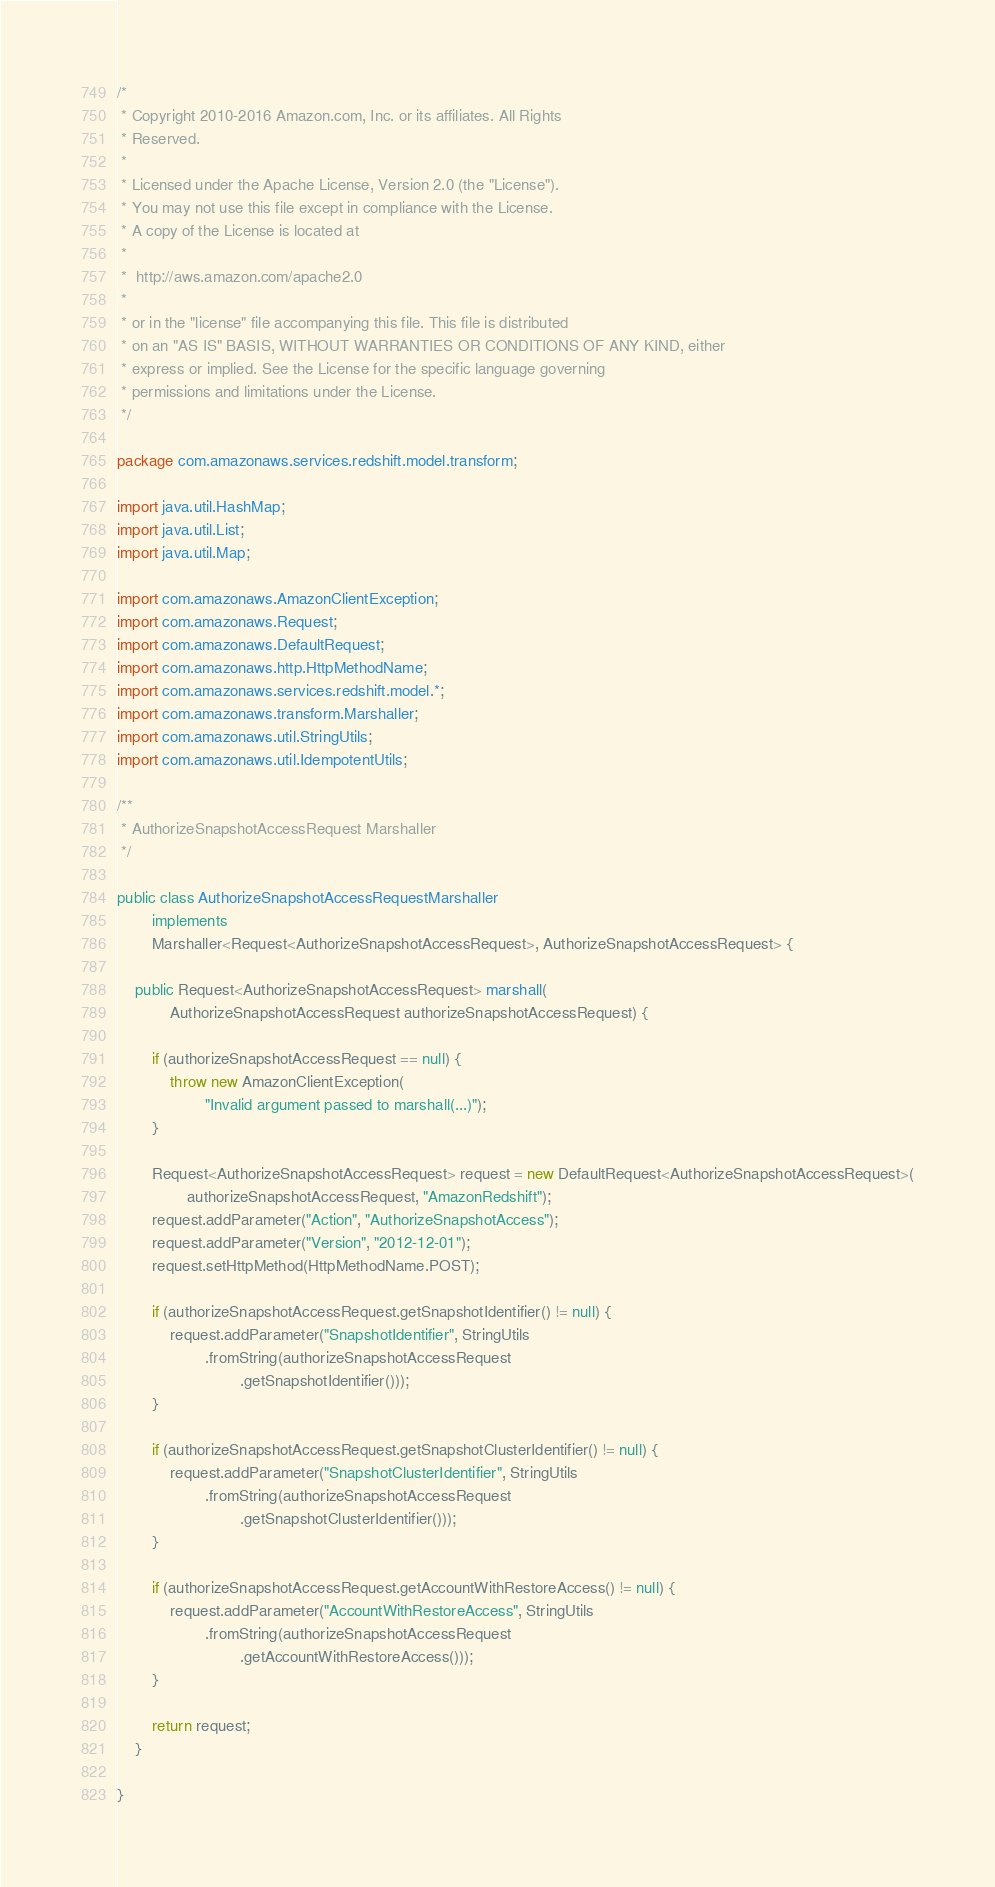<code> <loc_0><loc_0><loc_500><loc_500><_Java_>/*
 * Copyright 2010-2016 Amazon.com, Inc. or its affiliates. All Rights
 * Reserved.
 *
 * Licensed under the Apache License, Version 2.0 (the "License").
 * You may not use this file except in compliance with the License.
 * A copy of the License is located at
 *
 *  http://aws.amazon.com/apache2.0
 *
 * or in the "license" file accompanying this file. This file is distributed
 * on an "AS IS" BASIS, WITHOUT WARRANTIES OR CONDITIONS OF ANY KIND, either
 * express or implied. See the License for the specific language governing
 * permissions and limitations under the License.
 */

package com.amazonaws.services.redshift.model.transform;

import java.util.HashMap;
import java.util.List;
import java.util.Map;

import com.amazonaws.AmazonClientException;
import com.amazonaws.Request;
import com.amazonaws.DefaultRequest;
import com.amazonaws.http.HttpMethodName;
import com.amazonaws.services.redshift.model.*;
import com.amazonaws.transform.Marshaller;
import com.amazonaws.util.StringUtils;
import com.amazonaws.util.IdempotentUtils;

/**
 * AuthorizeSnapshotAccessRequest Marshaller
 */

public class AuthorizeSnapshotAccessRequestMarshaller
        implements
        Marshaller<Request<AuthorizeSnapshotAccessRequest>, AuthorizeSnapshotAccessRequest> {

    public Request<AuthorizeSnapshotAccessRequest> marshall(
            AuthorizeSnapshotAccessRequest authorizeSnapshotAccessRequest) {

        if (authorizeSnapshotAccessRequest == null) {
            throw new AmazonClientException(
                    "Invalid argument passed to marshall(...)");
        }

        Request<AuthorizeSnapshotAccessRequest> request = new DefaultRequest<AuthorizeSnapshotAccessRequest>(
                authorizeSnapshotAccessRequest, "AmazonRedshift");
        request.addParameter("Action", "AuthorizeSnapshotAccess");
        request.addParameter("Version", "2012-12-01");
        request.setHttpMethod(HttpMethodName.POST);

        if (authorizeSnapshotAccessRequest.getSnapshotIdentifier() != null) {
            request.addParameter("SnapshotIdentifier", StringUtils
                    .fromString(authorizeSnapshotAccessRequest
                            .getSnapshotIdentifier()));
        }

        if (authorizeSnapshotAccessRequest.getSnapshotClusterIdentifier() != null) {
            request.addParameter("SnapshotClusterIdentifier", StringUtils
                    .fromString(authorizeSnapshotAccessRequest
                            .getSnapshotClusterIdentifier()));
        }

        if (authorizeSnapshotAccessRequest.getAccountWithRestoreAccess() != null) {
            request.addParameter("AccountWithRestoreAccess", StringUtils
                    .fromString(authorizeSnapshotAccessRequest
                            .getAccountWithRestoreAccess()));
        }

        return request;
    }

}
</code> 